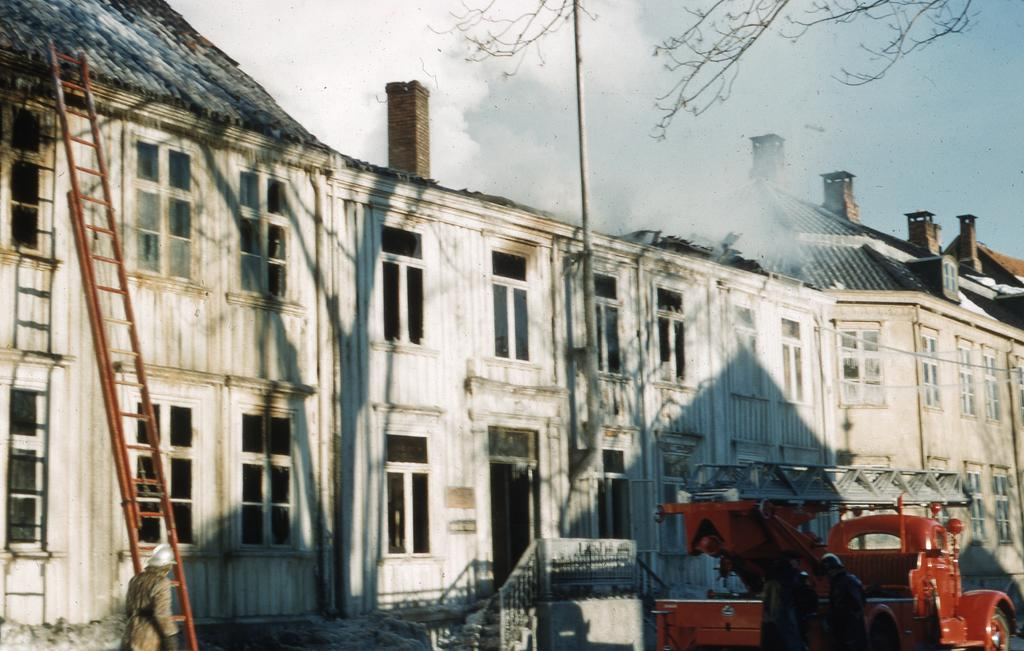What type of structures can be seen in the image? There are buildings in the image. What else is present in the image besides the buildings? There is a vehicle and a ladder in the image. How many people are in the image? There are three persons in the image. What can be seen in the background of the image? The sky is visible in the background of the image. What type of joke is being told by the government in the image? There is no reference to a joke or the government in the image; it features buildings, a vehicle, a ladder, and three persons. Is there a volcano visible in the image? No, there is no volcano present in the image. 